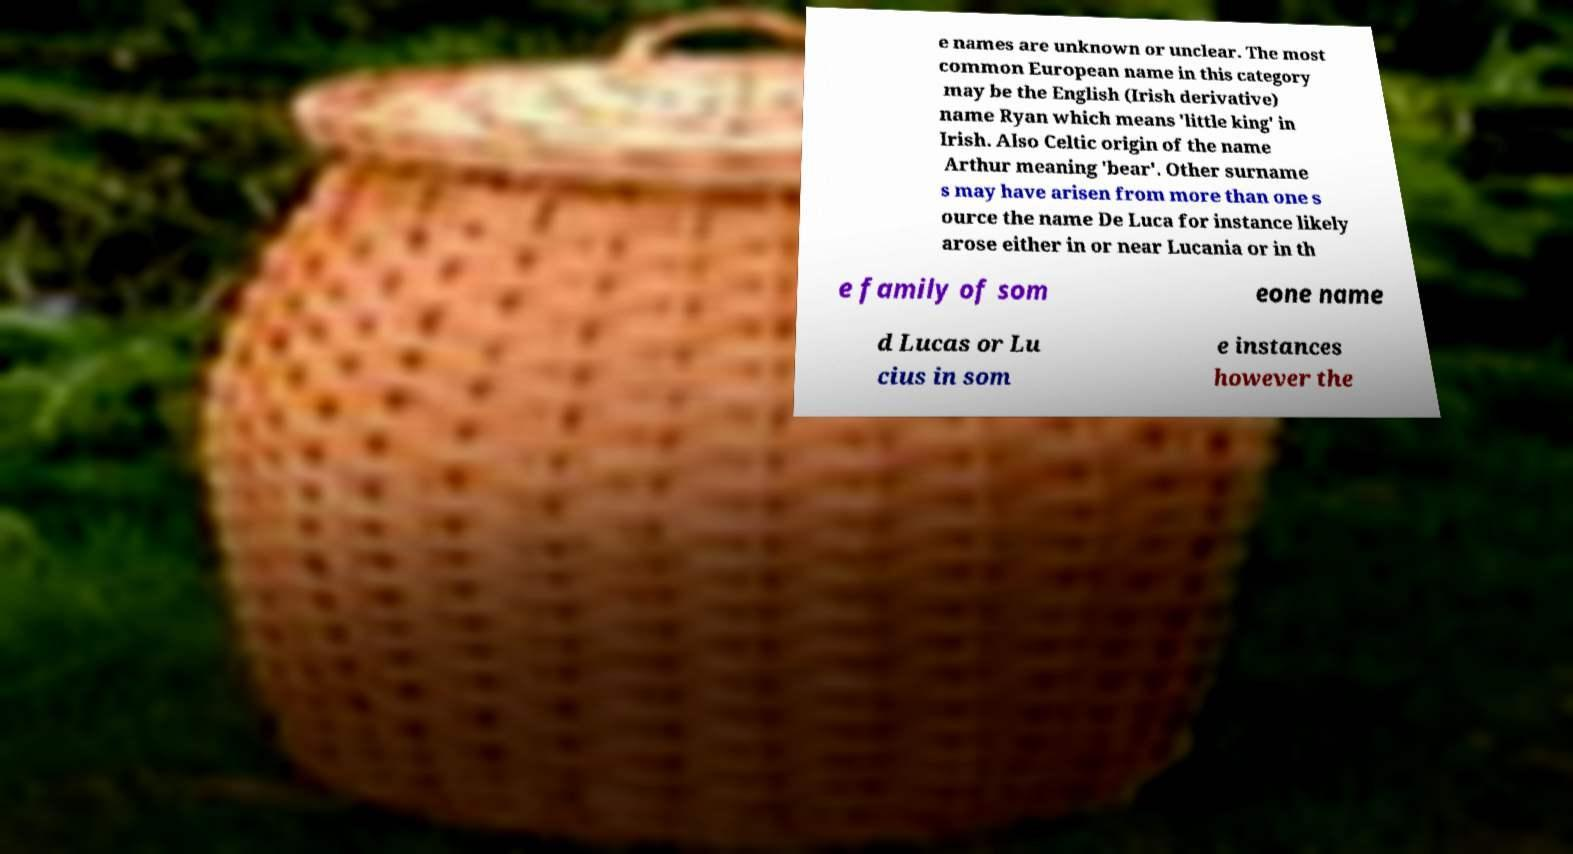There's text embedded in this image that I need extracted. Can you transcribe it verbatim? e names are unknown or unclear. The most common European name in this category may be the English (Irish derivative) name Ryan which means 'little king' in Irish. Also Celtic origin of the name Arthur meaning 'bear'. Other surname s may have arisen from more than one s ource the name De Luca for instance likely arose either in or near Lucania or in th e family of som eone name d Lucas or Lu cius in som e instances however the 